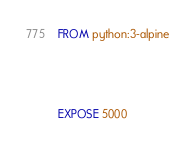<code> <loc_0><loc_0><loc_500><loc_500><_Dockerfile_>FROM python:3-alpine



EXPOSE 5000</code> 